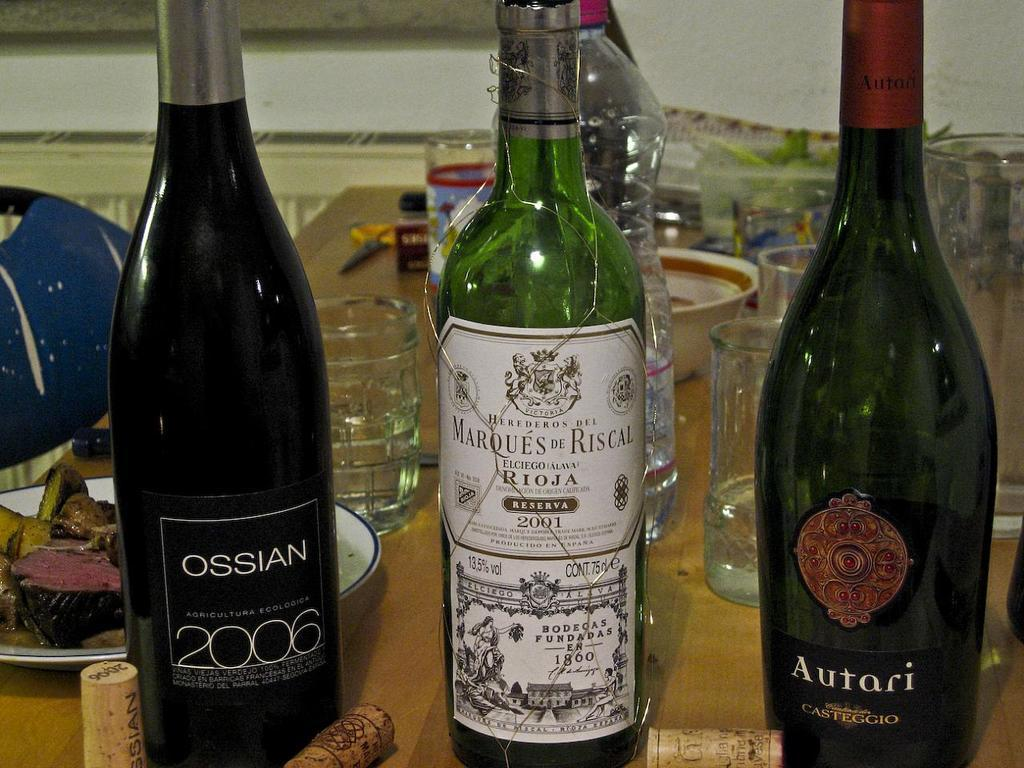<image>
Describe the image concisely. Three bottles of wine one is dark with a red logo on the front and says Autari underneath. 